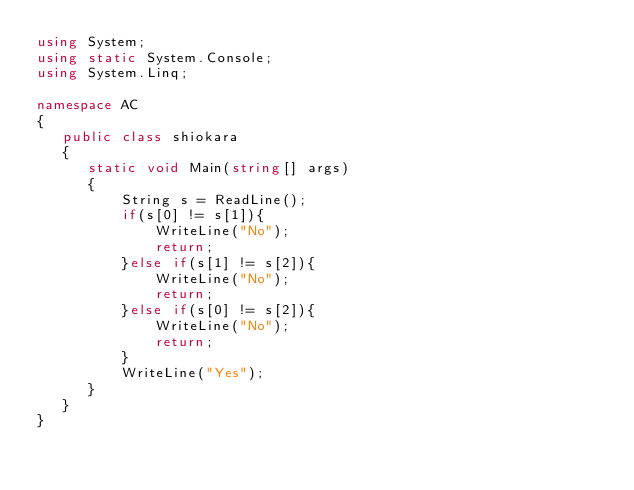Convert code to text. <code><loc_0><loc_0><loc_500><loc_500><_C#_>using System;
using static System.Console;
using System.Linq;

namespace AC
{
   public class shiokara
   {
      static void Main(string[] args)
      {
          String s = ReadLine();
          if(s[0] != s[1]){
              WriteLine("No");
              return;
          }else if(s[1] != s[2]){
              WriteLine("No");
              return;
          }else if(s[0] != s[2]){
              WriteLine("No");
              return;
          }
          WriteLine("Yes");
      }
   }
}</code> 